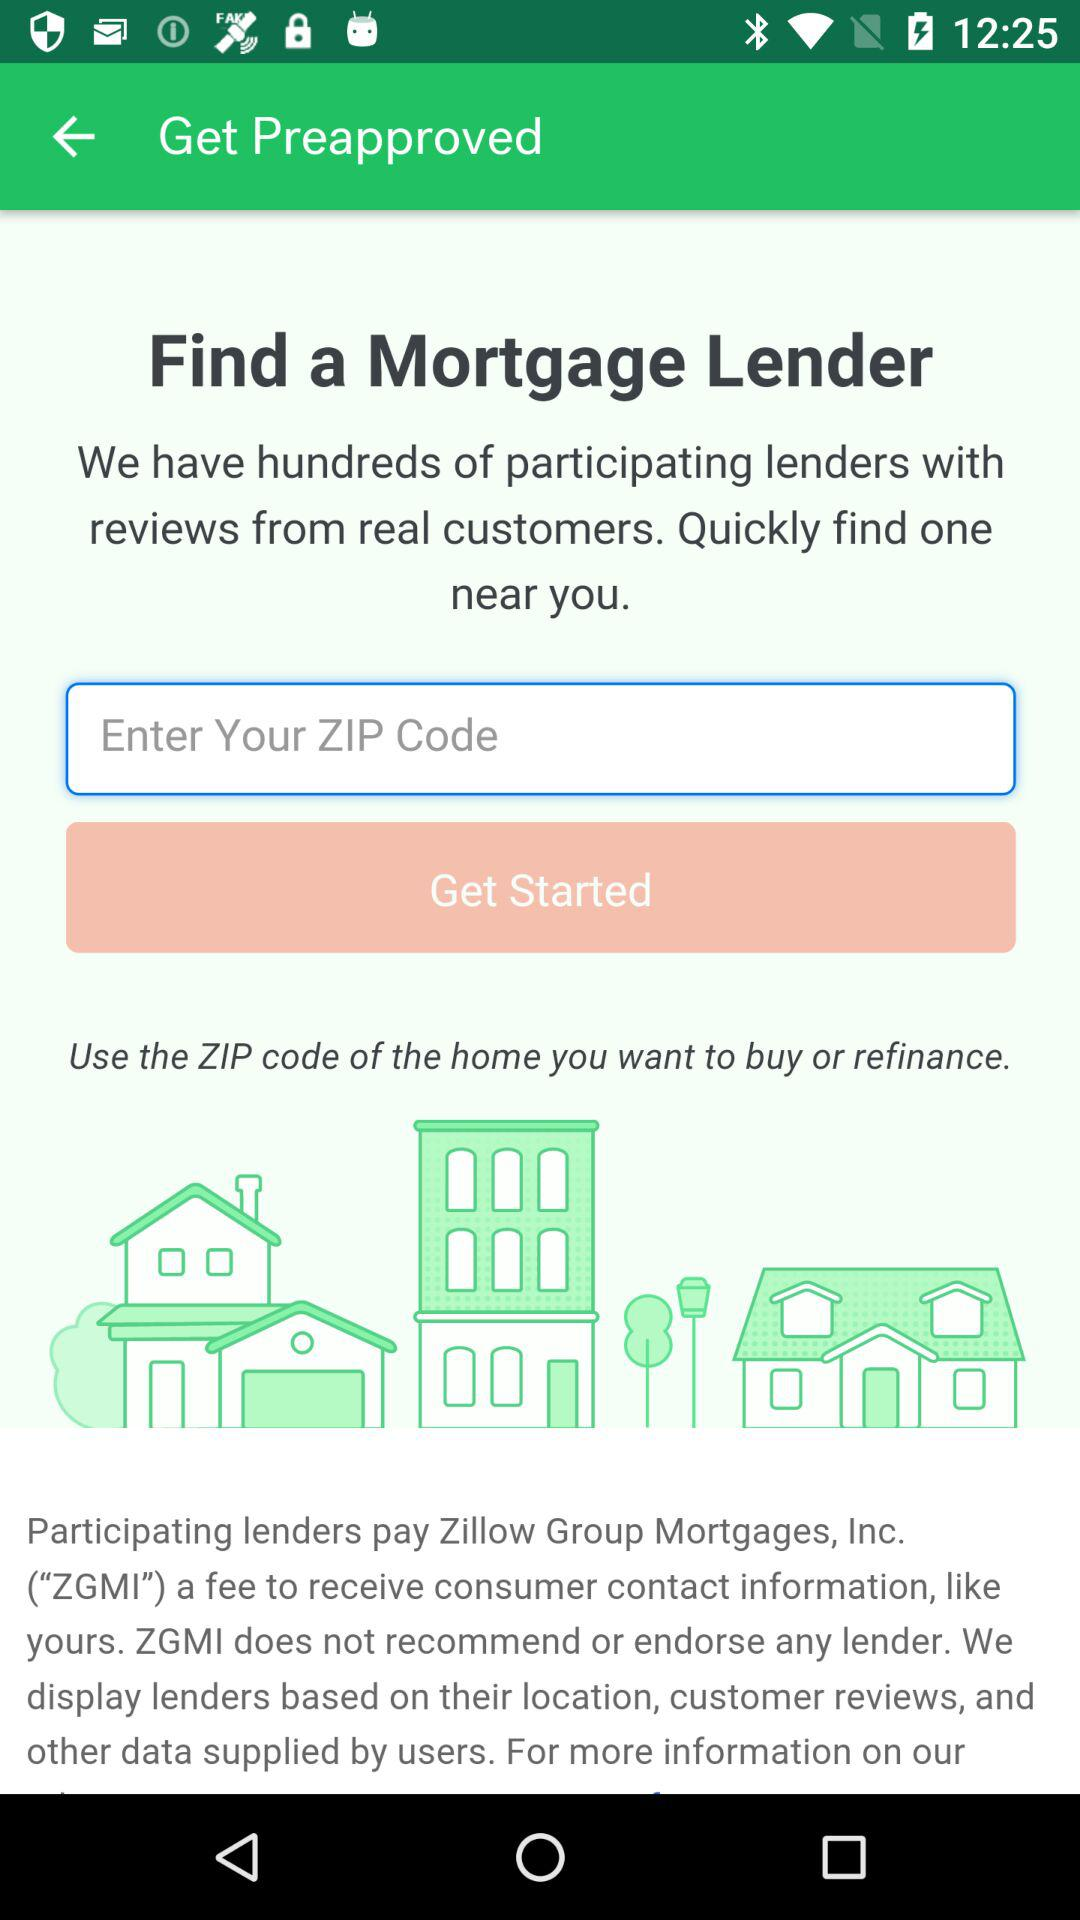What is the full form of ZGMI? The full form of ZGMI is "Zillow Group Mortgages, Inc.". 